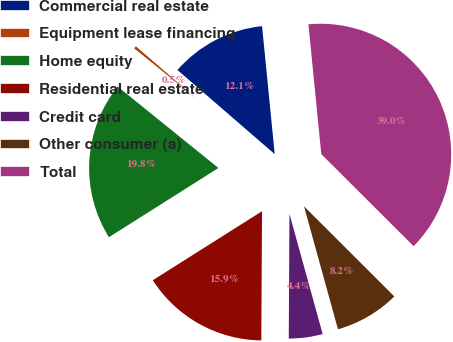Convert chart. <chart><loc_0><loc_0><loc_500><loc_500><pie_chart><fcel>Commercial real estate<fcel>Equipment lease financing<fcel>Home equity<fcel>Residential real estate<fcel>Credit card<fcel>Other consumer (a)<fcel>Total<nl><fcel>12.08%<fcel>0.53%<fcel>19.79%<fcel>15.94%<fcel>4.38%<fcel>8.23%<fcel>39.05%<nl></chart> 